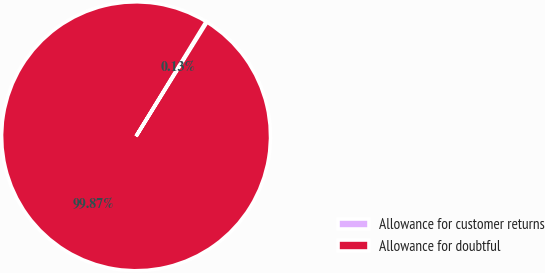<chart> <loc_0><loc_0><loc_500><loc_500><pie_chart><fcel>Allowance for customer returns<fcel>Allowance for doubtful<nl><fcel>0.13%<fcel>99.87%<nl></chart> 